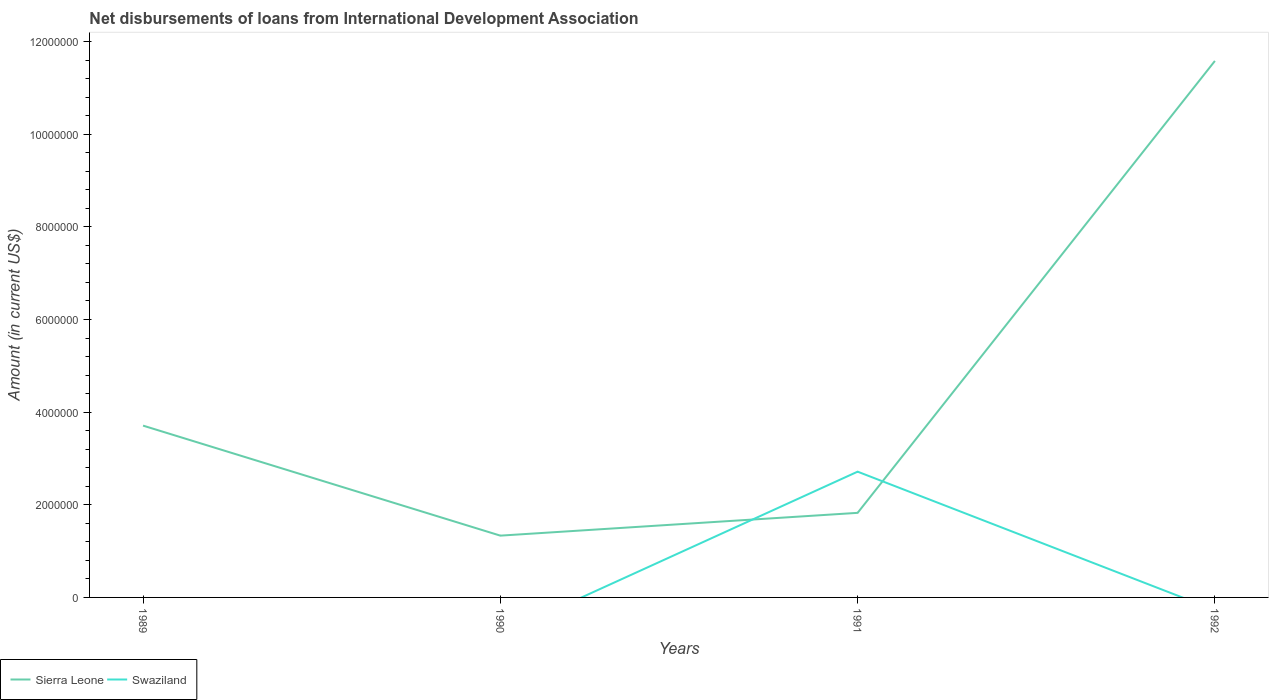How many different coloured lines are there?
Offer a terse response. 2. Does the line corresponding to Swaziland intersect with the line corresponding to Sierra Leone?
Make the answer very short. Yes. What is the total amount of loans disbursed in Sierra Leone in the graph?
Your answer should be compact. 2.38e+06. What is the difference between the highest and the second highest amount of loans disbursed in Sierra Leone?
Your response must be concise. 1.02e+07. Is the amount of loans disbursed in Swaziland strictly greater than the amount of loans disbursed in Sierra Leone over the years?
Provide a succinct answer. No. How many lines are there?
Make the answer very short. 2. How many years are there in the graph?
Your answer should be very brief. 4. Are the values on the major ticks of Y-axis written in scientific E-notation?
Provide a succinct answer. No. Where does the legend appear in the graph?
Keep it short and to the point. Bottom left. How many legend labels are there?
Give a very brief answer. 2. What is the title of the graph?
Provide a short and direct response. Net disbursements of loans from International Development Association. What is the label or title of the X-axis?
Your answer should be compact. Years. What is the Amount (in current US$) in Sierra Leone in 1989?
Offer a terse response. 3.71e+06. What is the Amount (in current US$) of Sierra Leone in 1990?
Your answer should be very brief. 1.33e+06. What is the Amount (in current US$) in Swaziland in 1990?
Your response must be concise. 0. What is the Amount (in current US$) in Sierra Leone in 1991?
Your response must be concise. 1.83e+06. What is the Amount (in current US$) in Swaziland in 1991?
Offer a terse response. 2.72e+06. What is the Amount (in current US$) in Sierra Leone in 1992?
Your answer should be very brief. 1.16e+07. Across all years, what is the maximum Amount (in current US$) of Sierra Leone?
Provide a succinct answer. 1.16e+07. Across all years, what is the maximum Amount (in current US$) of Swaziland?
Provide a succinct answer. 2.72e+06. Across all years, what is the minimum Amount (in current US$) of Sierra Leone?
Offer a terse response. 1.33e+06. Across all years, what is the minimum Amount (in current US$) in Swaziland?
Keep it short and to the point. 0. What is the total Amount (in current US$) in Sierra Leone in the graph?
Ensure brevity in your answer.  1.85e+07. What is the total Amount (in current US$) of Swaziland in the graph?
Provide a succinct answer. 2.72e+06. What is the difference between the Amount (in current US$) of Sierra Leone in 1989 and that in 1990?
Keep it short and to the point. 2.38e+06. What is the difference between the Amount (in current US$) of Sierra Leone in 1989 and that in 1991?
Make the answer very short. 1.88e+06. What is the difference between the Amount (in current US$) in Sierra Leone in 1989 and that in 1992?
Make the answer very short. -7.87e+06. What is the difference between the Amount (in current US$) in Sierra Leone in 1990 and that in 1991?
Keep it short and to the point. -4.92e+05. What is the difference between the Amount (in current US$) of Sierra Leone in 1990 and that in 1992?
Offer a very short reply. -1.02e+07. What is the difference between the Amount (in current US$) in Sierra Leone in 1991 and that in 1992?
Make the answer very short. -9.76e+06. What is the difference between the Amount (in current US$) of Sierra Leone in 1989 and the Amount (in current US$) of Swaziland in 1991?
Make the answer very short. 9.94e+05. What is the difference between the Amount (in current US$) of Sierra Leone in 1990 and the Amount (in current US$) of Swaziland in 1991?
Your answer should be very brief. -1.38e+06. What is the average Amount (in current US$) in Sierra Leone per year?
Make the answer very short. 4.61e+06. What is the average Amount (in current US$) in Swaziland per year?
Offer a terse response. 6.79e+05. In the year 1991, what is the difference between the Amount (in current US$) of Sierra Leone and Amount (in current US$) of Swaziland?
Your answer should be very brief. -8.89e+05. What is the ratio of the Amount (in current US$) of Sierra Leone in 1989 to that in 1990?
Your answer should be compact. 2.78. What is the ratio of the Amount (in current US$) in Sierra Leone in 1989 to that in 1991?
Give a very brief answer. 2.03. What is the ratio of the Amount (in current US$) of Sierra Leone in 1989 to that in 1992?
Provide a short and direct response. 0.32. What is the ratio of the Amount (in current US$) in Sierra Leone in 1990 to that in 1991?
Offer a terse response. 0.73. What is the ratio of the Amount (in current US$) of Sierra Leone in 1990 to that in 1992?
Offer a terse response. 0.12. What is the ratio of the Amount (in current US$) in Sierra Leone in 1991 to that in 1992?
Offer a very short reply. 0.16. What is the difference between the highest and the second highest Amount (in current US$) of Sierra Leone?
Give a very brief answer. 7.87e+06. What is the difference between the highest and the lowest Amount (in current US$) in Sierra Leone?
Your answer should be compact. 1.02e+07. What is the difference between the highest and the lowest Amount (in current US$) of Swaziland?
Keep it short and to the point. 2.72e+06. 